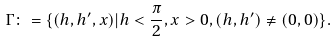Convert formula to latex. <formula><loc_0><loc_0><loc_500><loc_500>\Gamma \colon = \{ ( h , h ^ { \prime } , x ) | h < \frac { \pi } { 2 } , x > 0 , ( h , h ^ { \prime } ) \neq ( 0 , 0 ) \} .</formula> 